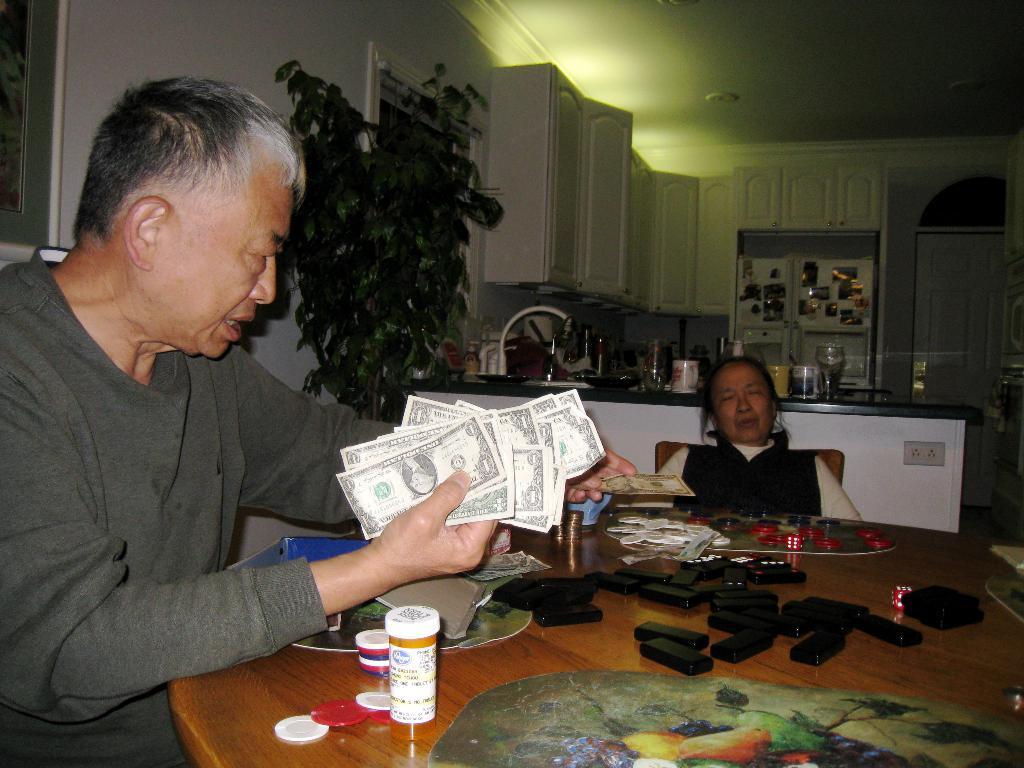How would you summarize this image in a sentence or two? The person wearing grey shirt is holding money in his hands and there is a woman sitting beside her and there is a table in front of them which has some objects on it. 